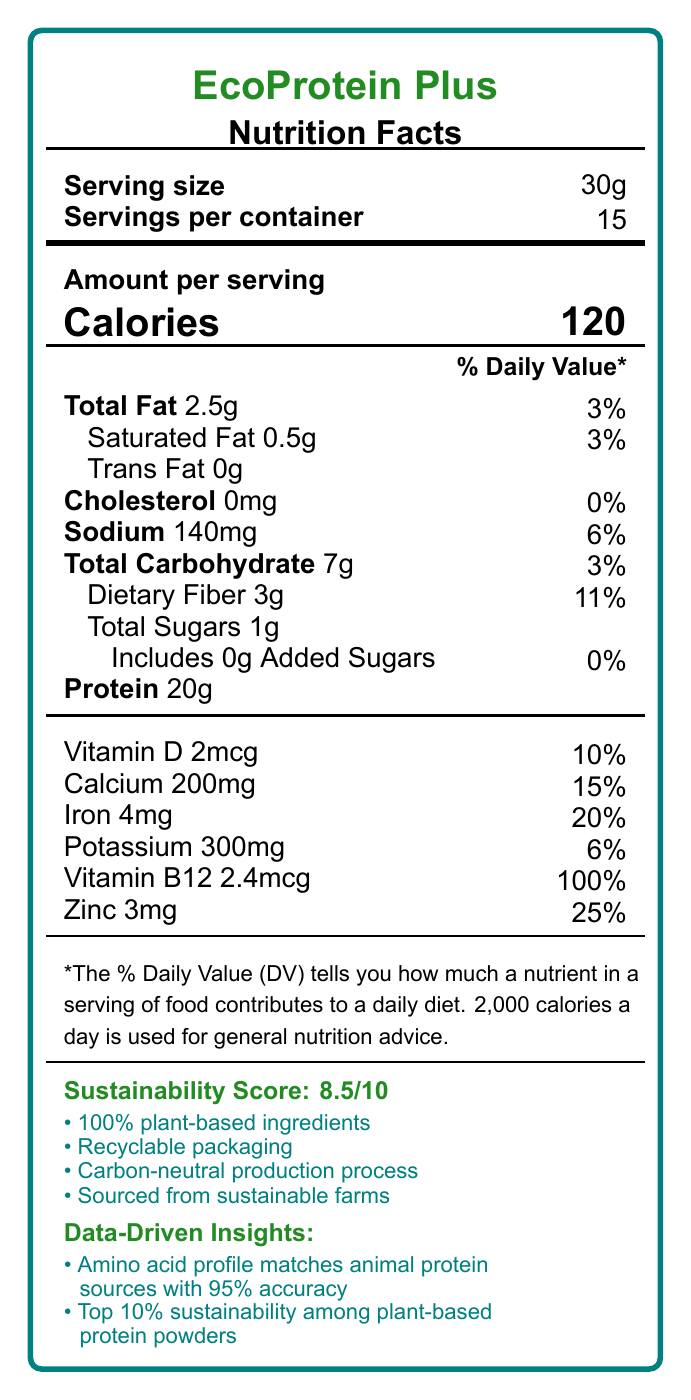what is the serving size? The serving size is directly listed as 30g in the document.
Answer: 30g how many calories are in one serving? The calorie content per serving is specified as 120.
Answer: 120 what is the total fat percentage of daily value per serving? Total fat daily value percentage per serving is mentioned as 3%.
Answer: 3% how much protein does one serving contain? The protein content per serving is directly noted as 20g.
Answer: 20g how many servings are there per container? The document specifies that there are 15 servings per container.
Answer: 15 how is the sustainability score represented? A. 7/10 B. 8/10 C. 8.5/10 D. 9/10 The sustainability score is stated as 8.5 out of 10.
Answer: C which vitamin provides 100% of its daily value per serving? A. Vitamin D B. Calcium C. Iron D. Vitamin B12 Vitamin B12 provides 100% of its daily value per serving.
Answer: D does the product contain any added sugars? The document mentions that the product contains 0g added sugars, which is 0% of the daily value.
Answer: No what allergen information is provided? The allergen information explicitly states that it is produced in a facility that also processes tree nuts and soy.
Answer: Produced in a facility that also processes tree nuts and soy what are the main components of the sustainability score? These components are listed under the sustainability score in the document.
Answer: 100% plant-based ingredients, Recyclable packaging, Carbon-neutral production process, Sourced from sustainable farms what are the data-driven insights mentioned in the document? The data-driven insights include the product's amino acid profile accuracy and its sustainability ranking.
Answer: Amino acid profile matches animal protein sources with 95% accuracy, Top 10% sustainability among plant-based protein powders what is the total carbohydrate content per serving? The total carbohydrate content per serving is mentioned as 7g.
Answer: 7g what percentage of daily value of dietary fiber does one serving provide? Dietary fiber daily value percentage per serving is stated as 11%.
Answer: 11% describe the product according to the document? This summary encapsulates key details about EcoProtein Plus, including nutritional information, sustainability score, and data-driven insights from the document.
Answer: EcoProtein Plus is a plant-based, complete protein source with added vitamins and minerals. Each serving size is 30g, providing 120 calories, 2.5g total fat, 7g total carbohydrates, 3g dietary fiber, and 20g protein. The product also contains essential vitamins and minerals like Vitamin D, Calcium, Iron, Potassium, Vitamin B12, and Zinc. It has a sustainability score of 8.5/10, reflecting its plant-based ingredients, recyclable packaging, carbon-neutral production process, and sustainable sourcing. Data-driven insights highlight its amino acid profile's accuracy and high sustainability ranking. what machine learning algorithm was used for calculating the sustainability score? The document does not include any specific details about the machine learning algorithm used for calculating the sustainability score.
Answer: Cannot be determined 